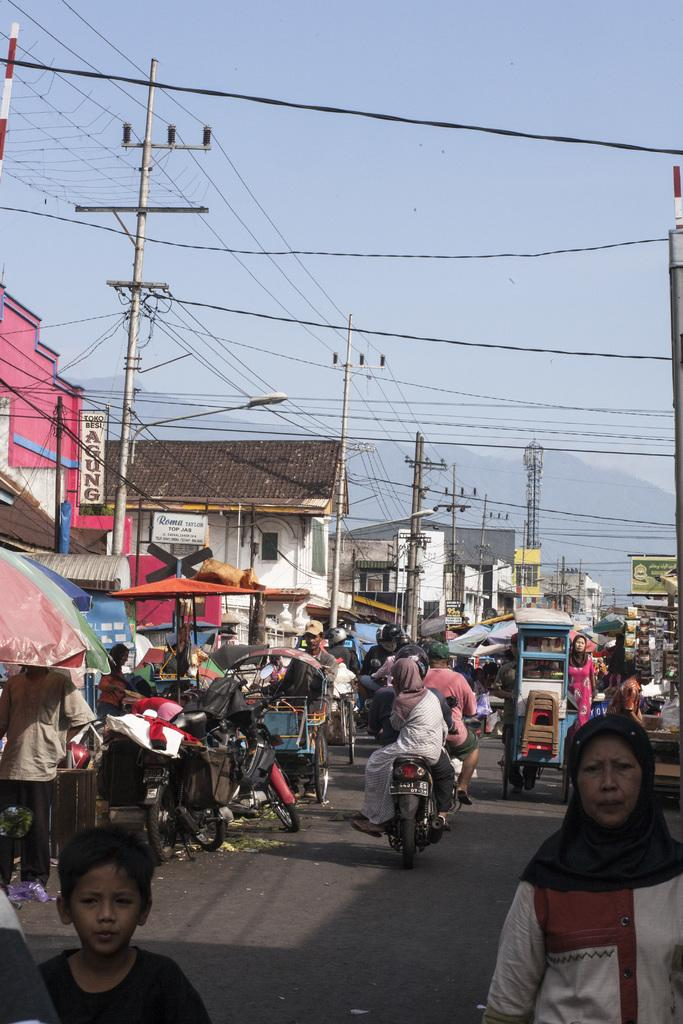What are the people in the image doing? There are people standing on the road and sitting on a bike in the image. What else can be seen in the image besides people? There are vehicles and buildings in the image. What is the condition of the sky in the image? The sky is clear in the image. Can you tell me the income of the snail in the image? There is no snail present in the image, so it is not possible to determine its income. 